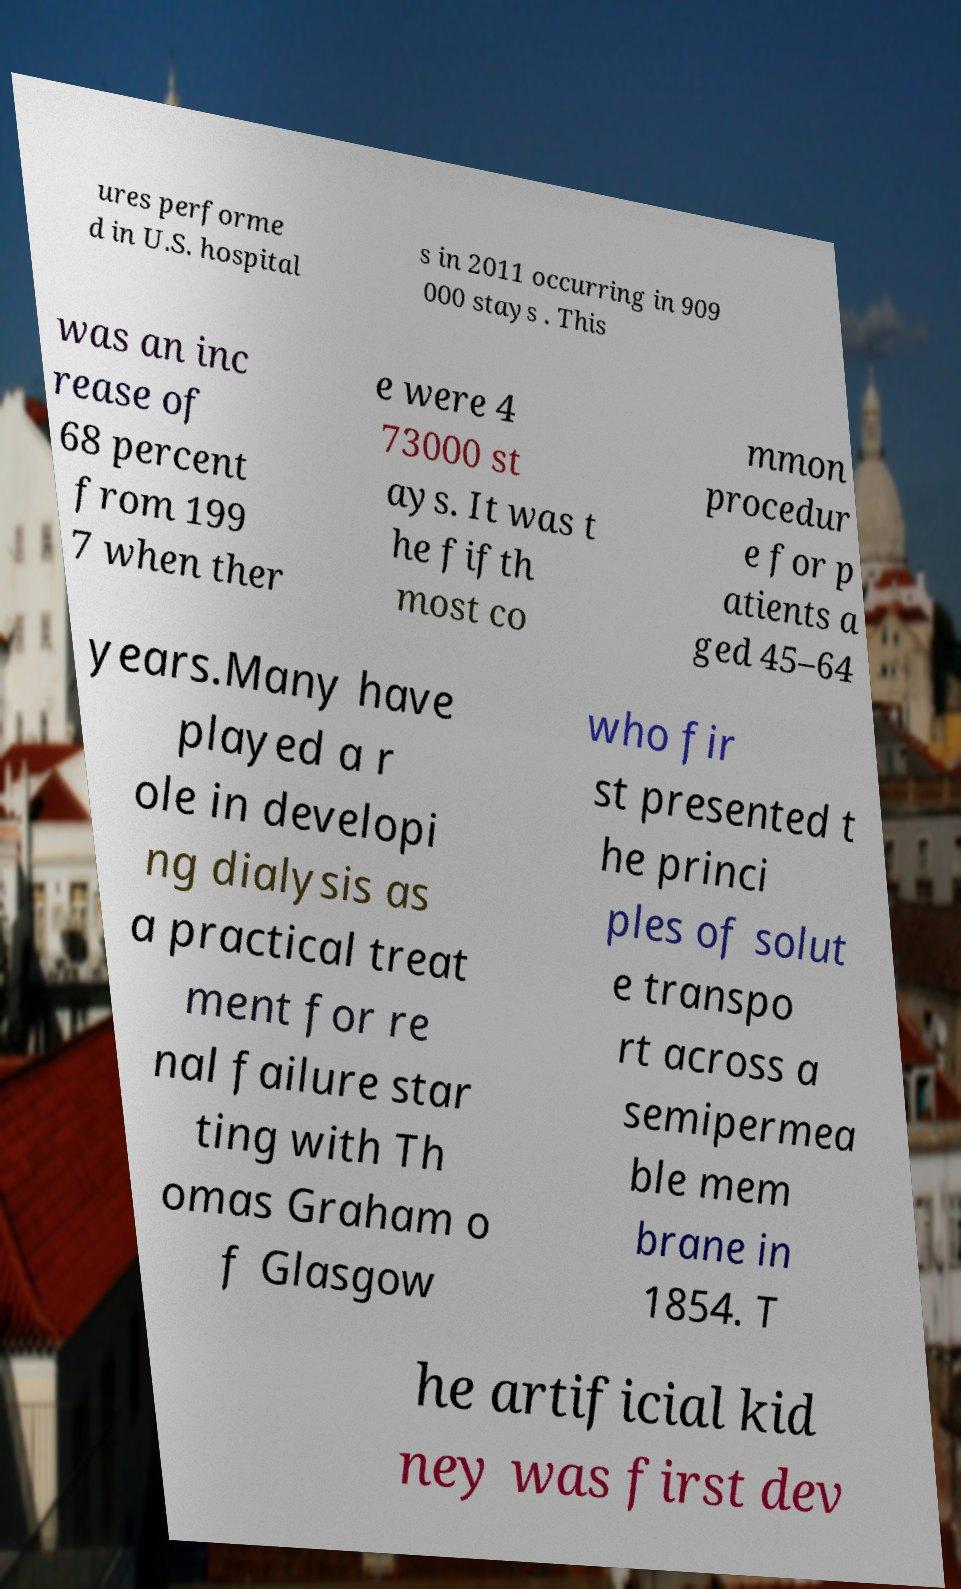Please identify and transcribe the text found in this image. ures performe d in U.S. hospital s in 2011 occurring in 909 000 stays . This was an inc rease of 68 percent from 199 7 when ther e were 4 73000 st ays. It was t he fifth most co mmon procedur e for p atients a ged 45–64 years.Many have played a r ole in developi ng dialysis as a practical treat ment for re nal failure star ting with Th omas Graham o f Glasgow who fir st presented t he princi ples of solut e transpo rt across a semipermea ble mem brane in 1854. T he artificial kid ney was first dev 